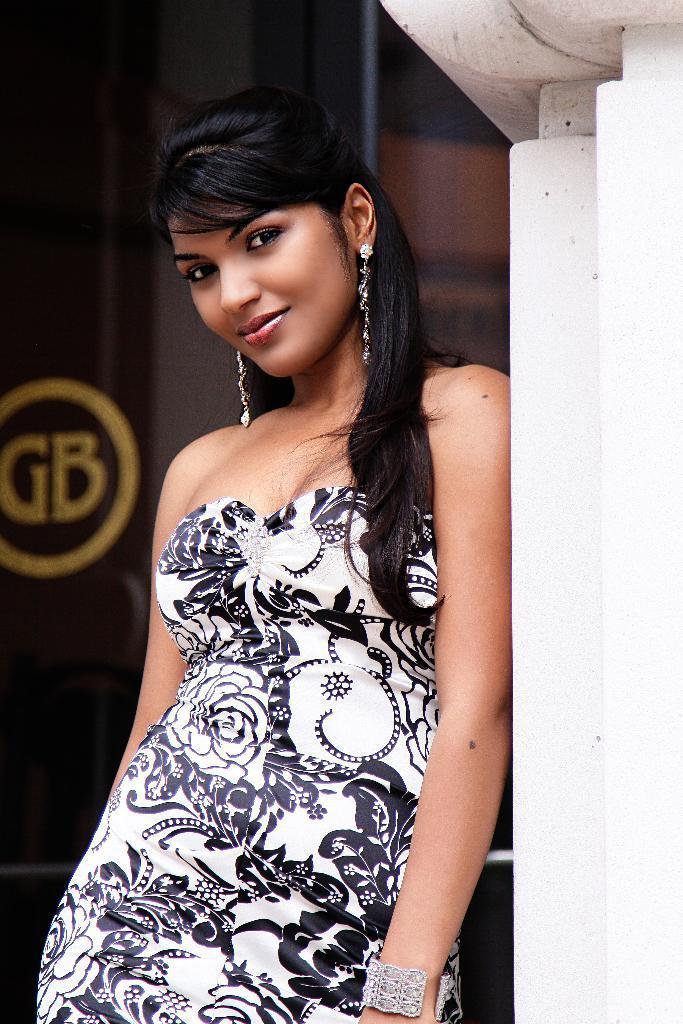How would you summarize this image in a sentence or two? The woman in white dress is standing in front of the picture. She is smiling. She is posing for the photo. Beside her, we see a white wall. Behind her, it is black in color and we see a pole in black color. 